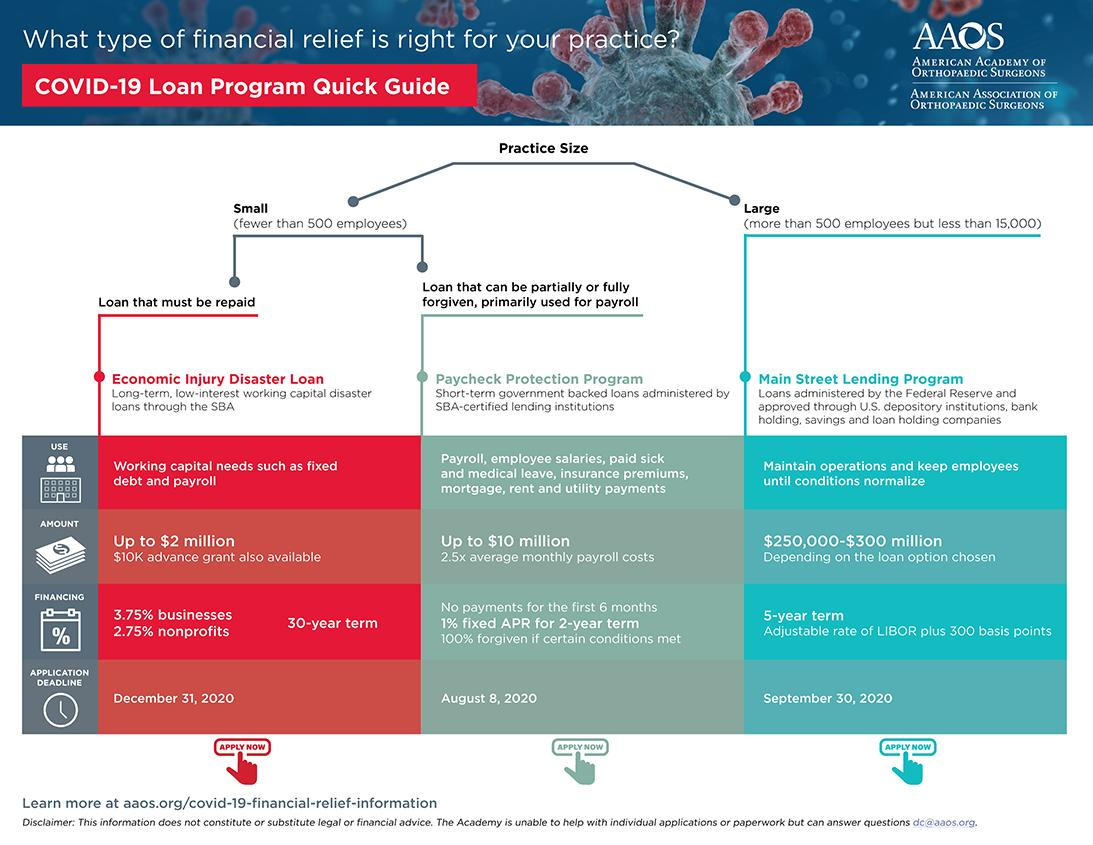Indicate a few pertinent items in this graphic. The maximum Economic Injury Disaster Loan amount is $2 million. The tenure of Economic Injury Disaster Loans is 30 years. The Paycheck Protection Program allows for loans up to a maximum of $10 million. The Main Street Leading Program loan has a tenure of 5 years. The deadline for submitting a loan application for the Paycheck Protection Program is August 8, 2020. 